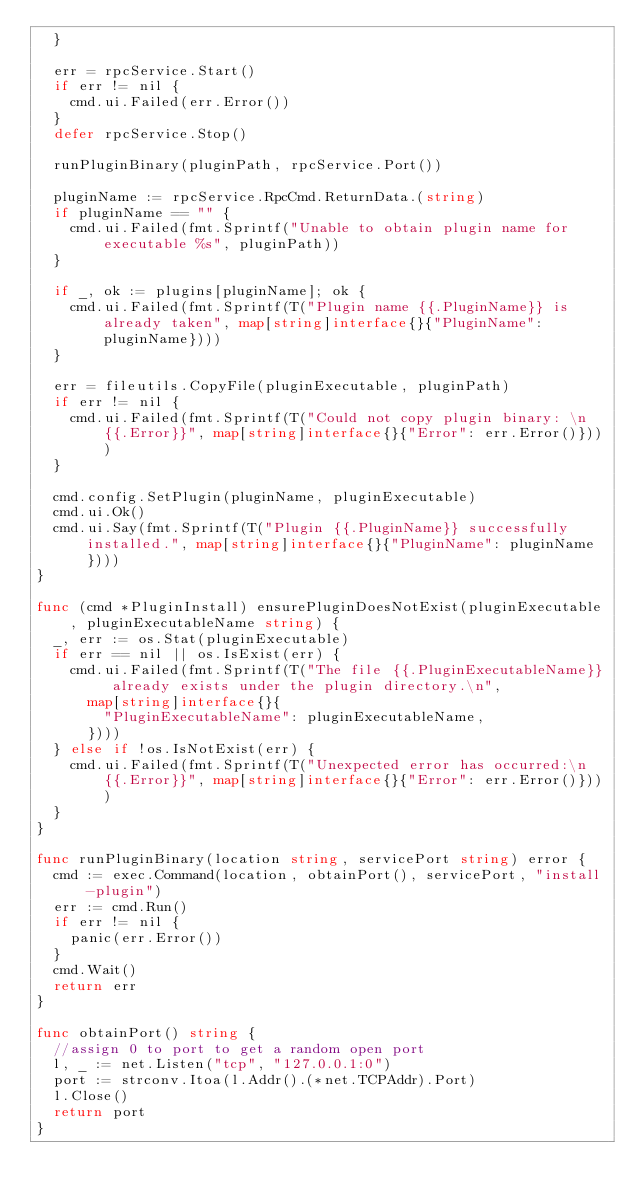Convert code to text. <code><loc_0><loc_0><loc_500><loc_500><_Go_>	}

	err = rpcService.Start()
	if err != nil {
		cmd.ui.Failed(err.Error())
	}
	defer rpcService.Stop()

	runPluginBinary(pluginPath, rpcService.Port())

	pluginName := rpcService.RpcCmd.ReturnData.(string)
	if pluginName == "" {
		cmd.ui.Failed(fmt.Sprintf("Unable to obtain plugin name for executable %s", pluginPath))
	}

	if _, ok := plugins[pluginName]; ok {
		cmd.ui.Failed(fmt.Sprintf(T("Plugin name {{.PluginName}} is already taken", map[string]interface{}{"PluginName": pluginName})))
	}

	err = fileutils.CopyFile(pluginExecutable, pluginPath)
	if err != nil {
		cmd.ui.Failed(fmt.Sprintf(T("Could not copy plugin binary: \n{{.Error}}", map[string]interface{}{"Error": err.Error()})))
	}

	cmd.config.SetPlugin(pluginName, pluginExecutable)
	cmd.ui.Ok()
	cmd.ui.Say(fmt.Sprintf(T("Plugin {{.PluginName}} successfully installed.", map[string]interface{}{"PluginName": pluginName})))
}

func (cmd *PluginInstall) ensurePluginDoesNotExist(pluginExecutable, pluginExecutableName string) {
	_, err := os.Stat(pluginExecutable)
	if err == nil || os.IsExist(err) {
		cmd.ui.Failed(fmt.Sprintf(T("The file {{.PluginExecutableName}} already exists under the plugin directory.\n",
			map[string]interface{}{
				"PluginExecutableName": pluginExecutableName,
			})))
	} else if !os.IsNotExist(err) {
		cmd.ui.Failed(fmt.Sprintf(T("Unexpected error has occurred:\n{{.Error}}", map[string]interface{}{"Error": err.Error()})))
	}
}

func runPluginBinary(location string, servicePort string) error {
	cmd := exec.Command(location, obtainPort(), servicePort, "install-plugin")
	err := cmd.Run()
	if err != nil {
		panic(err.Error())
	}
	cmd.Wait()
	return err
}

func obtainPort() string {
	//assign 0 to port to get a random open port
	l, _ := net.Listen("tcp", "127.0.0.1:0")
	port := strconv.Itoa(l.Addr().(*net.TCPAddr).Port)
	l.Close()
	return port
}
</code> 